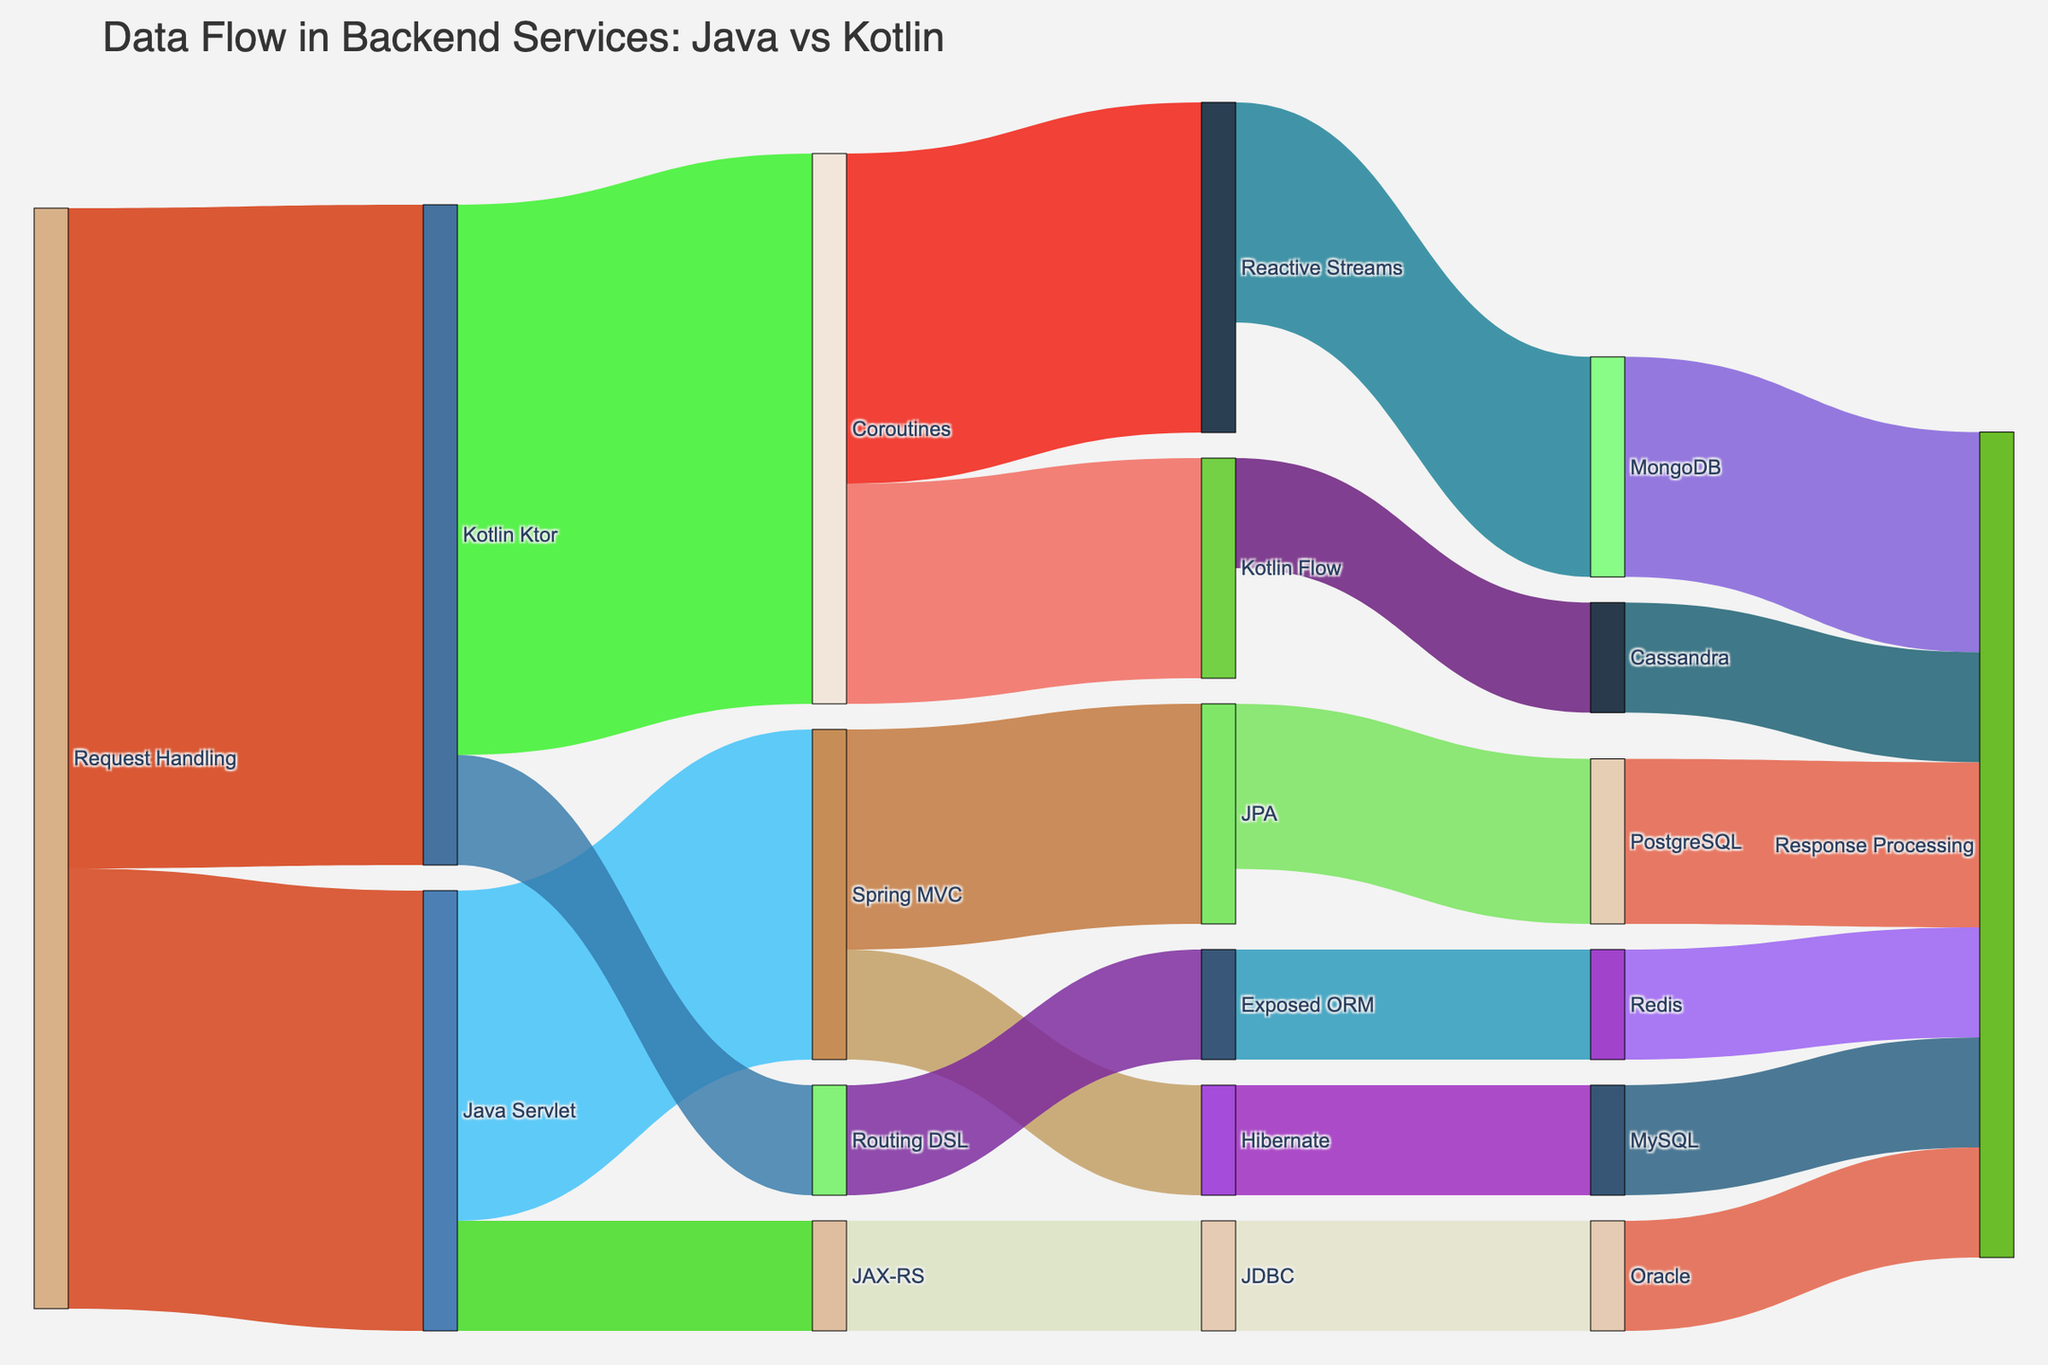What's the title of the figure? The title is usually placed at the top of the figure. In this case, it's "Data Flow in Backend Services: Java vs Kotlin".
Answer: Data Flow in Backend Services: Java vs Kotlin How many nodes are related to Kotlin Ktor? Look at the nodes directly connected to Kotlin Ktor. Kotlin Ktor is connected to Coroutines and Routing DSL.
Answer: 2 Which technology handles the highest number of requests? Examine the "Request Handling" node. Kotlin Ktor has a value of 60, which is higher than Java Servlet's 40.
Answer: Kotlin Ktor What is the total flow originating from Java Servlet? Sum the values from "Java Servlet". It's connected to Spring MVC (30) and JAX-RS (10). 30 + 10 = 40.
Answer: 40 Between Java and Kotlin approaches, which one utilizes Coroutines? Check which node is connected to Coroutines. Kotlin Ktor is connected to Coroutines.
Answer: Kotlin What's the total flow towards "Response Processing"? Add the values directed towards "Response Processing": PostgreSQL (15) + MySQL (10) + Oracle (10) + MongoDB (20) + Cassandra (10) + Redis (10). This equals 15 + 10 + 10 + 20 + 10 + 10 = 75.
Answer: 75 Which database is used by Spring MVC through JPA? Follow the flow from Spring MVC to JPA. It leads to PostgreSQL.
Answer: PostgreSQL Is the flow from Routing DSL greater than the flow from JAX-RS? Compare the values originating from Routing DSL (10) and JAX-RS (10). Both are equal.
Answer: No, they are equal Which technology has more interaction, Spring MVC or Coroutines? Observe the connections of both Spring MVC and Coroutines. Spring MVC connects to two nodes (JPA, Hibernate), and Coroutines connects to two nodes (Reactive Streams, Kotlin Flow). Both have equal interaction.
Answer: They have equal interaction What are the endpoints for Kotlin Flow? Trace the flow forward from Kotlin Flow. It leads to Cassandra.
Answer: Cassandra 